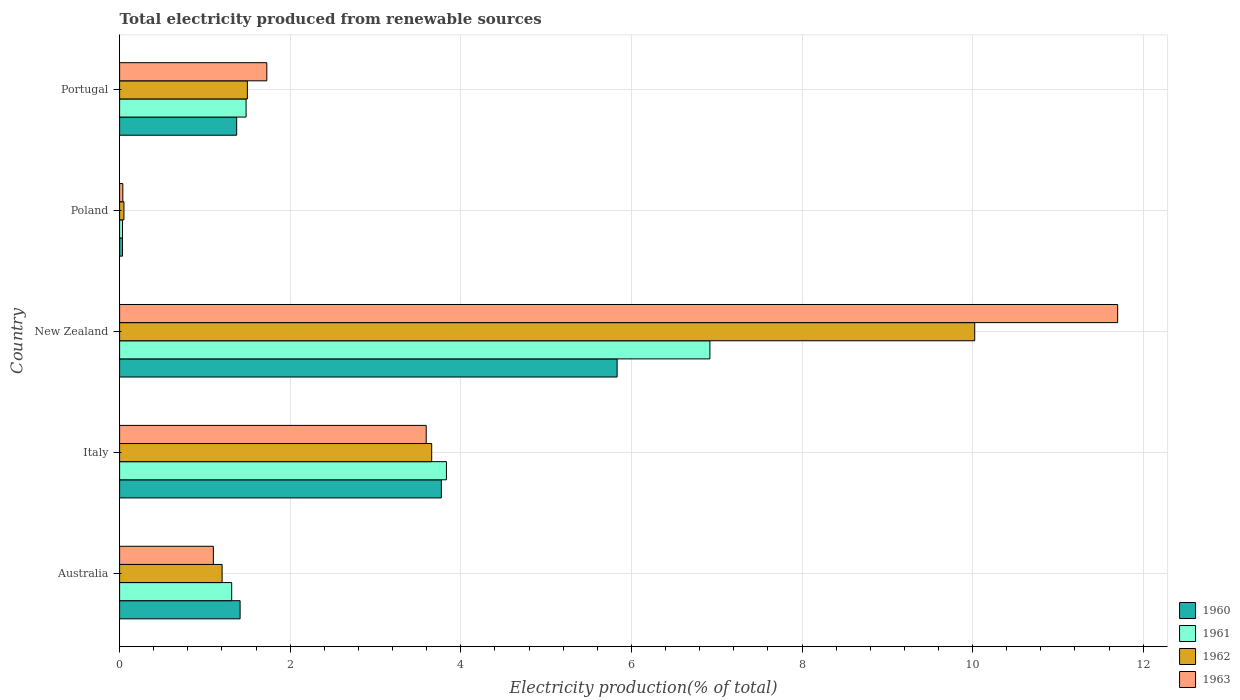How many different coloured bars are there?
Provide a short and direct response. 4. Are the number of bars per tick equal to the number of legend labels?
Ensure brevity in your answer.  Yes. What is the label of the 3rd group of bars from the top?
Keep it short and to the point. New Zealand. In how many cases, is the number of bars for a given country not equal to the number of legend labels?
Offer a very short reply. 0. What is the total electricity produced in 1962 in Australia?
Keep it short and to the point. 1.2. Across all countries, what is the maximum total electricity produced in 1963?
Give a very brief answer. 11.7. Across all countries, what is the minimum total electricity produced in 1962?
Ensure brevity in your answer.  0.05. In which country was the total electricity produced in 1960 maximum?
Make the answer very short. New Zealand. In which country was the total electricity produced in 1960 minimum?
Your answer should be compact. Poland. What is the total total electricity produced in 1962 in the graph?
Keep it short and to the point. 16.43. What is the difference between the total electricity produced in 1963 in Italy and that in Portugal?
Make the answer very short. 1.87. What is the difference between the total electricity produced in 1962 in Australia and the total electricity produced in 1963 in New Zealand?
Provide a succinct answer. -10.5. What is the average total electricity produced in 1961 per country?
Offer a very short reply. 2.72. What is the difference between the total electricity produced in 1960 and total electricity produced in 1961 in Poland?
Make the answer very short. 3.156606850160393e-5. What is the ratio of the total electricity produced in 1962 in Australia to that in New Zealand?
Give a very brief answer. 0.12. Is the total electricity produced in 1960 in Australia less than that in New Zealand?
Provide a succinct answer. Yes. What is the difference between the highest and the second highest total electricity produced in 1963?
Give a very brief answer. 8.11. What is the difference between the highest and the lowest total electricity produced in 1963?
Ensure brevity in your answer.  11.66. Is it the case that in every country, the sum of the total electricity produced in 1962 and total electricity produced in 1961 is greater than the sum of total electricity produced in 1963 and total electricity produced in 1960?
Give a very brief answer. No. What does the 1st bar from the top in New Zealand represents?
Make the answer very short. 1963. How many bars are there?
Provide a succinct answer. 20. Does the graph contain any zero values?
Provide a short and direct response. No. How many legend labels are there?
Ensure brevity in your answer.  4. What is the title of the graph?
Offer a very short reply. Total electricity produced from renewable sources. What is the label or title of the X-axis?
Keep it short and to the point. Electricity production(% of total). What is the label or title of the Y-axis?
Your response must be concise. Country. What is the Electricity production(% of total) of 1960 in Australia?
Provide a short and direct response. 1.41. What is the Electricity production(% of total) in 1961 in Australia?
Give a very brief answer. 1.31. What is the Electricity production(% of total) of 1962 in Australia?
Provide a succinct answer. 1.2. What is the Electricity production(% of total) of 1963 in Australia?
Your answer should be very brief. 1.1. What is the Electricity production(% of total) of 1960 in Italy?
Make the answer very short. 3.77. What is the Electricity production(% of total) of 1961 in Italy?
Offer a very short reply. 3.83. What is the Electricity production(% of total) in 1962 in Italy?
Your response must be concise. 3.66. What is the Electricity production(% of total) of 1963 in Italy?
Ensure brevity in your answer.  3.59. What is the Electricity production(% of total) of 1960 in New Zealand?
Your answer should be compact. 5.83. What is the Electricity production(% of total) in 1961 in New Zealand?
Keep it short and to the point. 6.92. What is the Electricity production(% of total) in 1962 in New Zealand?
Provide a succinct answer. 10.02. What is the Electricity production(% of total) in 1963 in New Zealand?
Keep it short and to the point. 11.7. What is the Electricity production(% of total) of 1960 in Poland?
Provide a succinct answer. 0.03. What is the Electricity production(% of total) of 1961 in Poland?
Provide a short and direct response. 0.03. What is the Electricity production(% of total) of 1962 in Poland?
Offer a terse response. 0.05. What is the Electricity production(% of total) in 1963 in Poland?
Offer a terse response. 0.04. What is the Electricity production(% of total) of 1960 in Portugal?
Provide a succinct answer. 1.37. What is the Electricity production(% of total) in 1961 in Portugal?
Provide a short and direct response. 1.48. What is the Electricity production(% of total) in 1962 in Portugal?
Your answer should be compact. 1.5. What is the Electricity production(% of total) of 1963 in Portugal?
Your answer should be compact. 1.73. Across all countries, what is the maximum Electricity production(% of total) of 1960?
Provide a short and direct response. 5.83. Across all countries, what is the maximum Electricity production(% of total) of 1961?
Ensure brevity in your answer.  6.92. Across all countries, what is the maximum Electricity production(% of total) of 1962?
Keep it short and to the point. 10.02. Across all countries, what is the maximum Electricity production(% of total) of 1963?
Your answer should be compact. 11.7. Across all countries, what is the minimum Electricity production(% of total) of 1960?
Offer a terse response. 0.03. Across all countries, what is the minimum Electricity production(% of total) in 1961?
Your answer should be compact. 0.03. Across all countries, what is the minimum Electricity production(% of total) in 1962?
Ensure brevity in your answer.  0.05. Across all countries, what is the minimum Electricity production(% of total) of 1963?
Your response must be concise. 0.04. What is the total Electricity production(% of total) in 1960 in the graph?
Ensure brevity in your answer.  12.42. What is the total Electricity production(% of total) in 1961 in the graph?
Give a very brief answer. 13.58. What is the total Electricity production(% of total) of 1962 in the graph?
Keep it short and to the point. 16.43. What is the total Electricity production(% of total) of 1963 in the graph?
Ensure brevity in your answer.  18.16. What is the difference between the Electricity production(% of total) in 1960 in Australia and that in Italy?
Ensure brevity in your answer.  -2.36. What is the difference between the Electricity production(% of total) in 1961 in Australia and that in Italy?
Provide a succinct answer. -2.52. What is the difference between the Electricity production(% of total) in 1962 in Australia and that in Italy?
Offer a very short reply. -2.46. What is the difference between the Electricity production(% of total) of 1963 in Australia and that in Italy?
Keep it short and to the point. -2.5. What is the difference between the Electricity production(% of total) of 1960 in Australia and that in New Zealand?
Provide a short and direct response. -4.42. What is the difference between the Electricity production(% of total) in 1961 in Australia and that in New Zealand?
Give a very brief answer. -5.61. What is the difference between the Electricity production(% of total) of 1962 in Australia and that in New Zealand?
Offer a very short reply. -8.82. What is the difference between the Electricity production(% of total) in 1963 in Australia and that in New Zealand?
Provide a short and direct response. -10.6. What is the difference between the Electricity production(% of total) in 1960 in Australia and that in Poland?
Keep it short and to the point. 1.38. What is the difference between the Electricity production(% of total) in 1961 in Australia and that in Poland?
Provide a succinct answer. 1.28. What is the difference between the Electricity production(% of total) of 1962 in Australia and that in Poland?
Offer a terse response. 1.15. What is the difference between the Electricity production(% of total) in 1963 in Australia and that in Poland?
Your response must be concise. 1.06. What is the difference between the Electricity production(% of total) in 1960 in Australia and that in Portugal?
Offer a very short reply. 0.04. What is the difference between the Electricity production(% of total) in 1961 in Australia and that in Portugal?
Your answer should be very brief. -0.17. What is the difference between the Electricity production(% of total) in 1962 in Australia and that in Portugal?
Offer a very short reply. -0.3. What is the difference between the Electricity production(% of total) of 1963 in Australia and that in Portugal?
Offer a terse response. -0.63. What is the difference between the Electricity production(% of total) of 1960 in Italy and that in New Zealand?
Your answer should be very brief. -2.06. What is the difference between the Electricity production(% of total) of 1961 in Italy and that in New Zealand?
Your response must be concise. -3.09. What is the difference between the Electricity production(% of total) in 1962 in Italy and that in New Zealand?
Your answer should be very brief. -6.37. What is the difference between the Electricity production(% of total) in 1963 in Italy and that in New Zealand?
Provide a short and direct response. -8.11. What is the difference between the Electricity production(% of total) of 1960 in Italy and that in Poland?
Offer a terse response. 3.74. What is the difference between the Electricity production(% of total) of 1961 in Italy and that in Poland?
Provide a succinct answer. 3.8. What is the difference between the Electricity production(% of total) of 1962 in Italy and that in Poland?
Offer a very short reply. 3.61. What is the difference between the Electricity production(% of total) in 1963 in Italy and that in Poland?
Your response must be concise. 3.56. What is the difference between the Electricity production(% of total) of 1960 in Italy and that in Portugal?
Your answer should be compact. 2.4. What is the difference between the Electricity production(% of total) of 1961 in Italy and that in Portugal?
Your answer should be compact. 2.35. What is the difference between the Electricity production(% of total) in 1962 in Italy and that in Portugal?
Give a very brief answer. 2.16. What is the difference between the Electricity production(% of total) in 1963 in Italy and that in Portugal?
Offer a very short reply. 1.87. What is the difference between the Electricity production(% of total) in 1960 in New Zealand and that in Poland?
Your answer should be very brief. 5.8. What is the difference between the Electricity production(% of total) in 1961 in New Zealand and that in Poland?
Offer a very short reply. 6.89. What is the difference between the Electricity production(% of total) in 1962 in New Zealand and that in Poland?
Your response must be concise. 9.97. What is the difference between the Electricity production(% of total) in 1963 in New Zealand and that in Poland?
Give a very brief answer. 11.66. What is the difference between the Electricity production(% of total) in 1960 in New Zealand and that in Portugal?
Provide a short and direct response. 4.46. What is the difference between the Electricity production(% of total) of 1961 in New Zealand and that in Portugal?
Offer a very short reply. 5.44. What is the difference between the Electricity production(% of total) of 1962 in New Zealand and that in Portugal?
Provide a succinct answer. 8.53. What is the difference between the Electricity production(% of total) of 1963 in New Zealand and that in Portugal?
Offer a very short reply. 9.97. What is the difference between the Electricity production(% of total) of 1960 in Poland and that in Portugal?
Your answer should be compact. -1.34. What is the difference between the Electricity production(% of total) of 1961 in Poland and that in Portugal?
Provide a short and direct response. -1.45. What is the difference between the Electricity production(% of total) of 1962 in Poland and that in Portugal?
Provide a short and direct response. -1.45. What is the difference between the Electricity production(% of total) of 1963 in Poland and that in Portugal?
Your response must be concise. -1.69. What is the difference between the Electricity production(% of total) in 1960 in Australia and the Electricity production(% of total) in 1961 in Italy?
Make the answer very short. -2.42. What is the difference between the Electricity production(% of total) of 1960 in Australia and the Electricity production(% of total) of 1962 in Italy?
Your response must be concise. -2.25. What is the difference between the Electricity production(% of total) in 1960 in Australia and the Electricity production(% of total) in 1963 in Italy?
Make the answer very short. -2.18. What is the difference between the Electricity production(% of total) of 1961 in Australia and the Electricity production(% of total) of 1962 in Italy?
Your answer should be compact. -2.34. What is the difference between the Electricity production(% of total) of 1961 in Australia and the Electricity production(% of total) of 1963 in Italy?
Your response must be concise. -2.28. What is the difference between the Electricity production(% of total) of 1962 in Australia and the Electricity production(% of total) of 1963 in Italy?
Offer a terse response. -2.39. What is the difference between the Electricity production(% of total) of 1960 in Australia and the Electricity production(% of total) of 1961 in New Zealand?
Your answer should be compact. -5.51. What is the difference between the Electricity production(% of total) in 1960 in Australia and the Electricity production(% of total) in 1962 in New Zealand?
Give a very brief answer. -8.61. What is the difference between the Electricity production(% of total) in 1960 in Australia and the Electricity production(% of total) in 1963 in New Zealand?
Offer a very short reply. -10.29. What is the difference between the Electricity production(% of total) in 1961 in Australia and the Electricity production(% of total) in 1962 in New Zealand?
Offer a very short reply. -8.71. What is the difference between the Electricity production(% of total) of 1961 in Australia and the Electricity production(% of total) of 1963 in New Zealand?
Your response must be concise. -10.39. What is the difference between the Electricity production(% of total) in 1962 in Australia and the Electricity production(% of total) in 1963 in New Zealand?
Your response must be concise. -10.5. What is the difference between the Electricity production(% of total) in 1960 in Australia and the Electricity production(% of total) in 1961 in Poland?
Offer a very short reply. 1.38. What is the difference between the Electricity production(% of total) in 1960 in Australia and the Electricity production(% of total) in 1962 in Poland?
Provide a succinct answer. 1.36. What is the difference between the Electricity production(% of total) of 1960 in Australia and the Electricity production(% of total) of 1963 in Poland?
Your response must be concise. 1.37. What is the difference between the Electricity production(% of total) of 1961 in Australia and the Electricity production(% of total) of 1962 in Poland?
Provide a short and direct response. 1.26. What is the difference between the Electricity production(% of total) of 1961 in Australia and the Electricity production(% of total) of 1963 in Poland?
Provide a short and direct response. 1.28. What is the difference between the Electricity production(% of total) in 1962 in Australia and the Electricity production(% of total) in 1963 in Poland?
Offer a terse response. 1.16. What is the difference between the Electricity production(% of total) of 1960 in Australia and the Electricity production(% of total) of 1961 in Portugal?
Your response must be concise. -0.07. What is the difference between the Electricity production(% of total) of 1960 in Australia and the Electricity production(% of total) of 1962 in Portugal?
Offer a very short reply. -0.09. What is the difference between the Electricity production(% of total) of 1960 in Australia and the Electricity production(% of total) of 1963 in Portugal?
Give a very brief answer. -0.31. What is the difference between the Electricity production(% of total) of 1961 in Australia and the Electricity production(% of total) of 1962 in Portugal?
Make the answer very short. -0.18. What is the difference between the Electricity production(% of total) in 1961 in Australia and the Electricity production(% of total) in 1963 in Portugal?
Offer a terse response. -0.41. What is the difference between the Electricity production(% of total) in 1962 in Australia and the Electricity production(% of total) in 1963 in Portugal?
Offer a very short reply. -0.52. What is the difference between the Electricity production(% of total) of 1960 in Italy and the Electricity production(% of total) of 1961 in New Zealand?
Provide a succinct answer. -3.15. What is the difference between the Electricity production(% of total) in 1960 in Italy and the Electricity production(% of total) in 1962 in New Zealand?
Your answer should be very brief. -6.25. What is the difference between the Electricity production(% of total) of 1960 in Italy and the Electricity production(% of total) of 1963 in New Zealand?
Make the answer very short. -7.93. What is the difference between the Electricity production(% of total) in 1961 in Italy and the Electricity production(% of total) in 1962 in New Zealand?
Provide a short and direct response. -6.19. What is the difference between the Electricity production(% of total) in 1961 in Italy and the Electricity production(% of total) in 1963 in New Zealand?
Make the answer very short. -7.87. What is the difference between the Electricity production(% of total) of 1962 in Italy and the Electricity production(% of total) of 1963 in New Zealand?
Your answer should be very brief. -8.04. What is the difference between the Electricity production(% of total) in 1960 in Italy and the Electricity production(% of total) in 1961 in Poland?
Provide a succinct answer. 3.74. What is the difference between the Electricity production(% of total) of 1960 in Italy and the Electricity production(% of total) of 1962 in Poland?
Make the answer very short. 3.72. What is the difference between the Electricity production(% of total) in 1960 in Italy and the Electricity production(% of total) in 1963 in Poland?
Make the answer very short. 3.73. What is the difference between the Electricity production(% of total) of 1961 in Italy and the Electricity production(% of total) of 1962 in Poland?
Provide a short and direct response. 3.78. What is the difference between the Electricity production(% of total) in 1961 in Italy and the Electricity production(% of total) in 1963 in Poland?
Offer a terse response. 3.79. What is the difference between the Electricity production(% of total) of 1962 in Italy and the Electricity production(% of total) of 1963 in Poland?
Your answer should be compact. 3.62. What is the difference between the Electricity production(% of total) in 1960 in Italy and the Electricity production(% of total) in 1961 in Portugal?
Your response must be concise. 2.29. What is the difference between the Electricity production(% of total) of 1960 in Italy and the Electricity production(% of total) of 1962 in Portugal?
Offer a very short reply. 2.27. What is the difference between the Electricity production(% of total) of 1960 in Italy and the Electricity production(% of total) of 1963 in Portugal?
Give a very brief answer. 2.05. What is the difference between the Electricity production(% of total) of 1961 in Italy and the Electricity production(% of total) of 1962 in Portugal?
Ensure brevity in your answer.  2.33. What is the difference between the Electricity production(% of total) in 1961 in Italy and the Electricity production(% of total) in 1963 in Portugal?
Make the answer very short. 2.11. What is the difference between the Electricity production(% of total) of 1962 in Italy and the Electricity production(% of total) of 1963 in Portugal?
Give a very brief answer. 1.93. What is the difference between the Electricity production(% of total) in 1960 in New Zealand and the Electricity production(% of total) in 1961 in Poland?
Give a very brief answer. 5.8. What is the difference between the Electricity production(% of total) of 1960 in New Zealand and the Electricity production(% of total) of 1962 in Poland?
Offer a very short reply. 5.78. What is the difference between the Electricity production(% of total) in 1960 in New Zealand and the Electricity production(% of total) in 1963 in Poland?
Provide a short and direct response. 5.79. What is the difference between the Electricity production(% of total) in 1961 in New Zealand and the Electricity production(% of total) in 1962 in Poland?
Ensure brevity in your answer.  6.87. What is the difference between the Electricity production(% of total) of 1961 in New Zealand and the Electricity production(% of total) of 1963 in Poland?
Offer a terse response. 6.88. What is the difference between the Electricity production(% of total) in 1962 in New Zealand and the Electricity production(% of total) in 1963 in Poland?
Keep it short and to the point. 9.99. What is the difference between the Electricity production(% of total) in 1960 in New Zealand and the Electricity production(% of total) in 1961 in Portugal?
Your answer should be compact. 4.35. What is the difference between the Electricity production(% of total) of 1960 in New Zealand and the Electricity production(% of total) of 1962 in Portugal?
Provide a short and direct response. 4.33. What is the difference between the Electricity production(% of total) in 1960 in New Zealand and the Electricity production(% of total) in 1963 in Portugal?
Your answer should be compact. 4.11. What is the difference between the Electricity production(% of total) of 1961 in New Zealand and the Electricity production(% of total) of 1962 in Portugal?
Give a very brief answer. 5.42. What is the difference between the Electricity production(% of total) in 1961 in New Zealand and the Electricity production(% of total) in 1963 in Portugal?
Offer a very short reply. 5.19. What is the difference between the Electricity production(% of total) of 1962 in New Zealand and the Electricity production(% of total) of 1963 in Portugal?
Your response must be concise. 8.3. What is the difference between the Electricity production(% of total) in 1960 in Poland and the Electricity production(% of total) in 1961 in Portugal?
Offer a terse response. -1.45. What is the difference between the Electricity production(% of total) in 1960 in Poland and the Electricity production(% of total) in 1962 in Portugal?
Offer a terse response. -1.46. What is the difference between the Electricity production(% of total) in 1960 in Poland and the Electricity production(% of total) in 1963 in Portugal?
Offer a very short reply. -1.69. What is the difference between the Electricity production(% of total) of 1961 in Poland and the Electricity production(% of total) of 1962 in Portugal?
Keep it short and to the point. -1.46. What is the difference between the Electricity production(% of total) of 1961 in Poland and the Electricity production(% of total) of 1963 in Portugal?
Your response must be concise. -1.69. What is the difference between the Electricity production(% of total) in 1962 in Poland and the Electricity production(% of total) in 1963 in Portugal?
Offer a terse response. -1.67. What is the average Electricity production(% of total) in 1960 per country?
Provide a short and direct response. 2.48. What is the average Electricity production(% of total) in 1961 per country?
Keep it short and to the point. 2.72. What is the average Electricity production(% of total) in 1962 per country?
Provide a short and direct response. 3.29. What is the average Electricity production(% of total) of 1963 per country?
Give a very brief answer. 3.63. What is the difference between the Electricity production(% of total) of 1960 and Electricity production(% of total) of 1961 in Australia?
Give a very brief answer. 0.1. What is the difference between the Electricity production(% of total) of 1960 and Electricity production(% of total) of 1962 in Australia?
Your response must be concise. 0.21. What is the difference between the Electricity production(% of total) of 1960 and Electricity production(% of total) of 1963 in Australia?
Give a very brief answer. 0.31. What is the difference between the Electricity production(% of total) of 1961 and Electricity production(% of total) of 1962 in Australia?
Offer a terse response. 0.11. What is the difference between the Electricity production(% of total) of 1961 and Electricity production(% of total) of 1963 in Australia?
Offer a very short reply. 0.21. What is the difference between the Electricity production(% of total) of 1962 and Electricity production(% of total) of 1963 in Australia?
Offer a terse response. 0.1. What is the difference between the Electricity production(% of total) of 1960 and Electricity production(% of total) of 1961 in Italy?
Give a very brief answer. -0.06. What is the difference between the Electricity production(% of total) in 1960 and Electricity production(% of total) in 1962 in Italy?
Keep it short and to the point. 0.11. What is the difference between the Electricity production(% of total) of 1960 and Electricity production(% of total) of 1963 in Italy?
Your answer should be very brief. 0.18. What is the difference between the Electricity production(% of total) of 1961 and Electricity production(% of total) of 1962 in Italy?
Your answer should be very brief. 0.17. What is the difference between the Electricity production(% of total) in 1961 and Electricity production(% of total) in 1963 in Italy?
Your response must be concise. 0.24. What is the difference between the Electricity production(% of total) of 1962 and Electricity production(% of total) of 1963 in Italy?
Your answer should be compact. 0.06. What is the difference between the Electricity production(% of total) in 1960 and Electricity production(% of total) in 1961 in New Zealand?
Make the answer very short. -1.09. What is the difference between the Electricity production(% of total) in 1960 and Electricity production(% of total) in 1962 in New Zealand?
Give a very brief answer. -4.19. What is the difference between the Electricity production(% of total) in 1960 and Electricity production(% of total) in 1963 in New Zealand?
Offer a very short reply. -5.87. What is the difference between the Electricity production(% of total) in 1961 and Electricity production(% of total) in 1962 in New Zealand?
Your answer should be very brief. -3.1. What is the difference between the Electricity production(% of total) in 1961 and Electricity production(% of total) in 1963 in New Zealand?
Provide a succinct answer. -4.78. What is the difference between the Electricity production(% of total) in 1962 and Electricity production(% of total) in 1963 in New Zealand?
Your answer should be very brief. -1.68. What is the difference between the Electricity production(% of total) in 1960 and Electricity production(% of total) in 1961 in Poland?
Your response must be concise. 0. What is the difference between the Electricity production(% of total) of 1960 and Electricity production(% of total) of 1962 in Poland?
Provide a succinct answer. -0.02. What is the difference between the Electricity production(% of total) of 1960 and Electricity production(% of total) of 1963 in Poland?
Provide a succinct answer. -0. What is the difference between the Electricity production(% of total) of 1961 and Electricity production(% of total) of 1962 in Poland?
Give a very brief answer. -0.02. What is the difference between the Electricity production(% of total) in 1961 and Electricity production(% of total) in 1963 in Poland?
Offer a terse response. -0. What is the difference between the Electricity production(% of total) in 1962 and Electricity production(% of total) in 1963 in Poland?
Keep it short and to the point. 0.01. What is the difference between the Electricity production(% of total) in 1960 and Electricity production(% of total) in 1961 in Portugal?
Your answer should be compact. -0.11. What is the difference between the Electricity production(% of total) of 1960 and Electricity production(% of total) of 1962 in Portugal?
Your answer should be very brief. -0.13. What is the difference between the Electricity production(% of total) in 1960 and Electricity production(% of total) in 1963 in Portugal?
Give a very brief answer. -0.35. What is the difference between the Electricity production(% of total) in 1961 and Electricity production(% of total) in 1962 in Portugal?
Your answer should be very brief. -0.02. What is the difference between the Electricity production(% of total) in 1961 and Electricity production(% of total) in 1963 in Portugal?
Your answer should be very brief. -0.24. What is the difference between the Electricity production(% of total) of 1962 and Electricity production(% of total) of 1963 in Portugal?
Your answer should be compact. -0.23. What is the ratio of the Electricity production(% of total) in 1960 in Australia to that in Italy?
Offer a terse response. 0.37. What is the ratio of the Electricity production(% of total) of 1961 in Australia to that in Italy?
Your answer should be very brief. 0.34. What is the ratio of the Electricity production(% of total) of 1962 in Australia to that in Italy?
Give a very brief answer. 0.33. What is the ratio of the Electricity production(% of total) in 1963 in Australia to that in Italy?
Provide a succinct answer. 0.31. What is the ratio of the Electricity production(% of total) of 1960 in Australia to that in New Zealand?
Provide a short and direct response. 0.24. What is the ratio of the Electricity production(% of total) in 1961 in Australia to that in New Zealand?
Provide a short and direct response. 0.19. What is the ratio of the Electricity production(% of total) in 1962 in Australia to that in New Zealand?
Provide a short and direct response. 0.12. What is the ratio of the Electricity production(% of total) in 1963 in Australia to that in New Zealand?
Your answer should be compact. 0.09. What is the ratio of the Electricity production(% of total) in 1960 in Australia to that in Poland?
Offer a very short reply. 41.37. What is the ratio of the Electricity production(% of total) in 1961 in Australia to that in Poland?
Offer a very short reply. 38.51. What is the ratio of the Electricity production(% of total) of 1962 in Australia to that in Poland?
Keep it short and to the point. 23.61. What is the ratio of the Electricity production(% of total) in 1963 in Australia to that in Poland?
Provide a short and direct response. 29. What is the ratio of the Electricity production(% of total) in 1960 in Australia to that in Portugal?
Your answer should be compact. 1.03. What is the ratio of the Electricity production(% of total) in 1961 in Australia to that in Portugal?
Keep it short and to the point. 0.89. What is the ratio of the Electricity production(% of total) in 1962 in Australia to that in Portugal?
Make the answer very short. 0.8. What is the ratio of the Electricity production(% of total) of 1963 in Australia to that in Portugal?
Keep it short and to the point. 0.64. What is the ratio of the Electricity production(% of total) in 1960 in Italy to that in New Zealand?
Make the answer very short. 0.65. What is the ratio of the Electricity production(% of total) of 1961 in Italy to that in New Zealand?
Provide a short and direct response. 0.55. What is the ratio of the Electricity production(% of total) in 1962 in Italy to that in New Zealand?
Ensure brevity in your answer.  0.36. What is the ratio of the Electricity production(% of total) of 1963 in Italy to that in New Zealand?
Keep it short and to the point. 0.31. What is the ratio of the Electricity production(% of total) in 1960 in Italy to that in Poland?
Keep it short and to the point. 110.45. What is the ratio of the Electricity production(% of total) in 1961 in Italy to that in Poland?
Offer a terse response. 112.3. What is the ratio of the Electricity production(% of total) in 1962 in Italy to that in Poland?
Make the answer very short. 71.88. What is the ratio of the Electricity production(% of total) of 1963 in Italy to that in Poland?
Provide a succinct answer. 94.84. What is the ratio of the Electricity production(% of total) of 1960 in Italy to that in Portugal?
Provide a short and direct response. 2.75. What is the ratio of the Electricity production(% of total) of 1961 in Italy to that in Portugal?
Your response must be concise. 2.58. What is the ratio of the Electricity production(% of total) of 1962 in Italy to that in Portugal?
Keep it short and to the point. 2.44. What is the ratio of the Electricity production(% of total) in 1963 in Italy to that in Portugal?
Your response must be concise. 2.08. What is the ratio of the Electricity production(% of total) of 1960 in New Zealand to that in Poland?
Offer a terse response. 170.79. What is the ratio of the Electricity production(% of total) in 1961 in New Zealand to that in Poland?
Offer a terse response. 202.83. What is the ratio of the Electricity production(% of total) of 1962 in New Zealand to that in Poland?
Keep it short and to the point. 196.95. What is the ratio of the Electricity production(% of total) in 1963 in New Zealand to that in Poland?
Keep it short and to the point. 308.73. What is the ratio of the Electricity production(% of total) in 1960 in New Zealand to that in Portugal?
Provide a succinct answer. 4.25. What is the ratio of the Electricity production(% of total) in 1961 in New Zealand to that in Portugal?
Ensure brevity in your answer.  4.67. What is the ratio of the Electricity production(% of total) of 1962 in New Zealand to that in Portugal?
Provide a short and direct response. 6.69. What is the ratio of the Electricity production(% of total) of 1963 in New Zealand to that in Portugal?
Make the answer very short. 6.78. What is the ratio of the Electricity production(% of total) of 1960 in Poland to that in Portugal?
Your answer should be very brief. 0.02. What is the ratio of the Electricity production(% of total) in 1961 in Poland to that in Portugal?
Provide a short and direct response. 0.02. What is the ratio of the Electricity production(% of total) in 1962 in Poland to that in Portugal?
Ensure brevity in your answer.  0.03. What is the ratio of the Electricity production(% of total) in 1963 in Poland to that in Portugal?
Offer a very short reply. 0.02. What is the difference between the highest and the second highest Electricity production(% of total) of 1960?
Keep it short and to the point. 2.06. What is the difference between the highest and the second highest Electricity production(% of total) of 1961?
Keep it short and to the point. 3.09. What is the difference between the highest and the second highest Electricity production(% of total) of 1962?
Provide a short and direct response. 6.37. What is the difference between the highest and the second highest Electricity production(% of total) in 1963?
Provide a succinct answer. 8.11. What is the difference between the highest and the lowest Electricity production(% of total) of 1960?
Make the answer very short. 5.8. What is the difference between the highest and the lowest Electricity production(% of total) of 1961?
Keep it short and to the point. 6.89. What is the difference between the highest and the lowest Electricity production(% of total) in 1962?
Make the answer very short. 9.97. What is the difference between the highest and the lowest Electricity production(% of total) of 1963?
Provide a succinct answer. 11.66. 